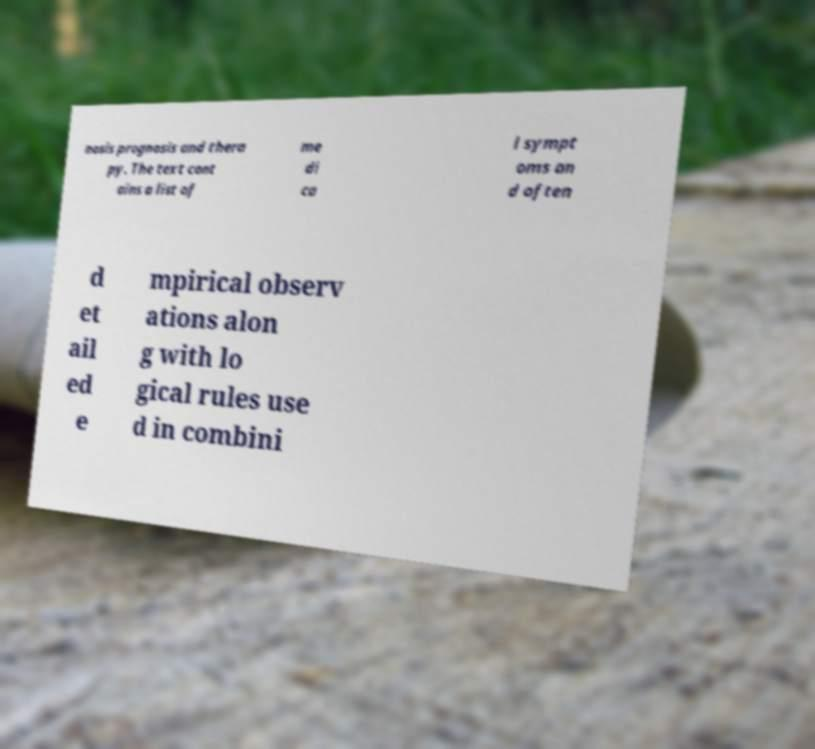Can you accurately transcribe the text from the provided image for me? nosis prognosis and thera py. The text cont ains a list of me di ca l sympt oms an d often d et ail ed e mpirical observ ations alon g with lo gical rules use d in combini 